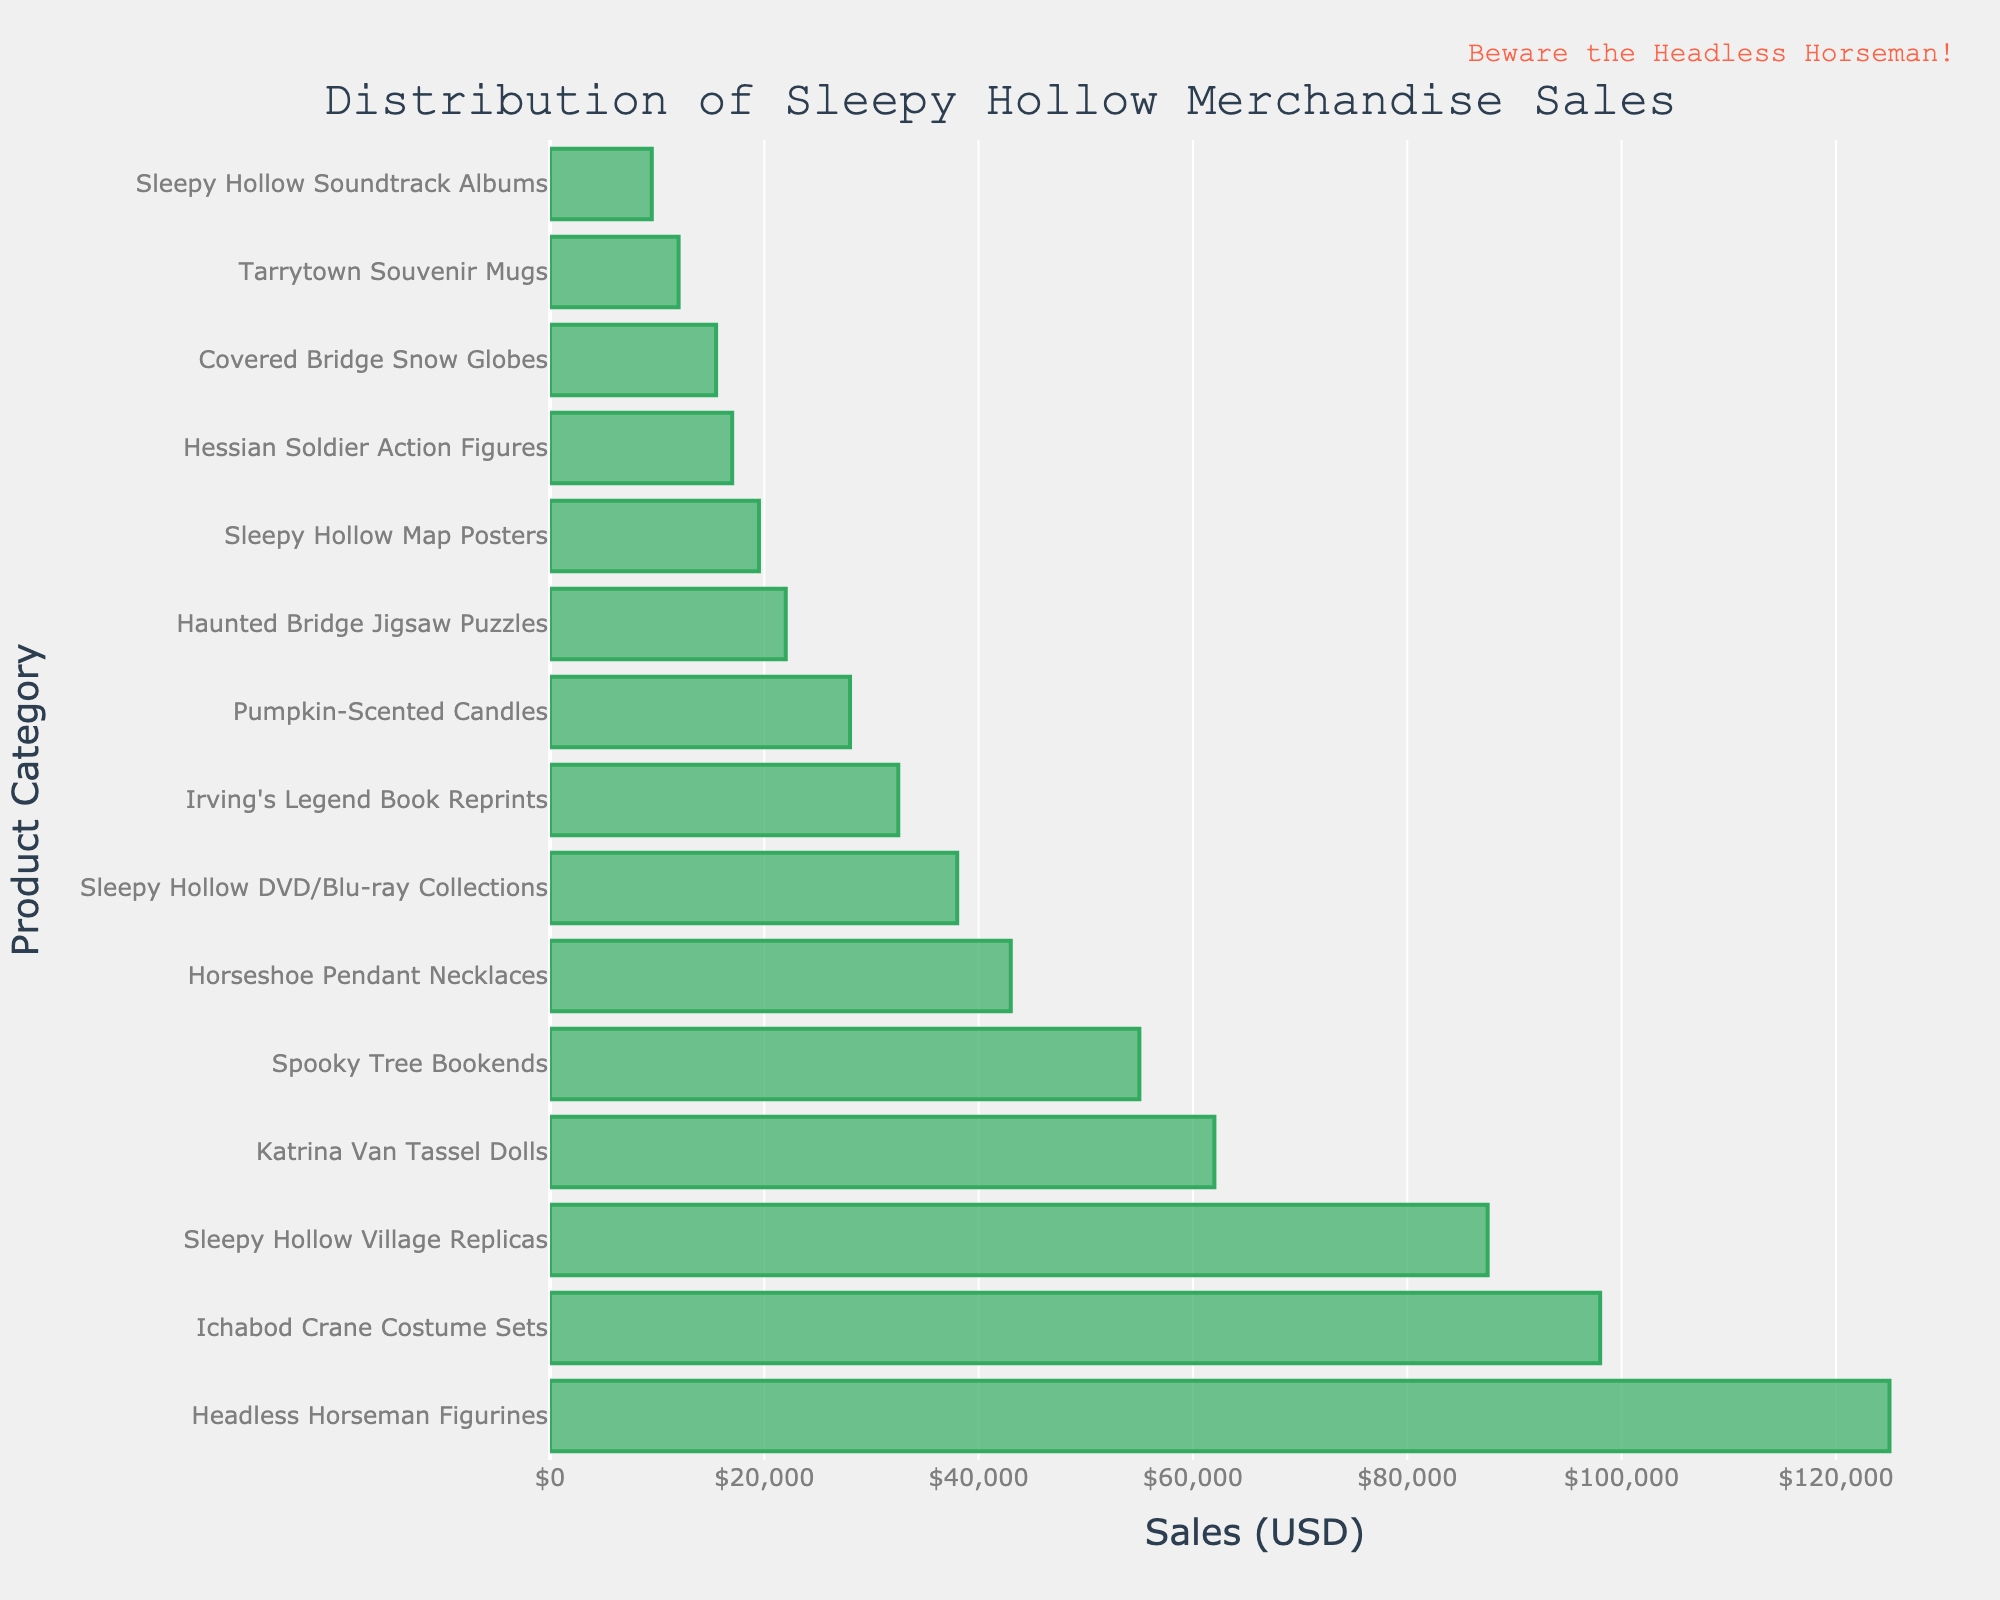Which product category has the highest sales? The product category with the highest sales is represented by the longest bar in the figure. The longest bar corresponds to "Headless Horseman Figurines".
Answer: Headless Horseman Figurines Which product category has the lowest sales? The product category with the lowest sales is represented by the shortest bar in the chart. The shortest bar corresponds to "Sleepy Hollow Soundtrack Albums".
Answer: Sleepy Hollow Soundtrack Albums Are the sales of "Ichabod Crane Costume Sets" higher or lower than "Katrina Van Tassel Dolls"? By comparing the lengths of the bars for "Ichabod Crane Costume Sets" and "Katrina Van Tassel Dolls", it is clear that "Ichabod Crane Costume Sets" has a longer bar, thus higher sales.
Answer: Higher What are the combined sales of "Headless Horseman Figurines" and "Sleepy Hollow Village Replicas"? By summing the sales of "Headless Horseman Figurines" ($125,000) and "Sleepy Hollow Village Replicas" ($87,500), we get $125,000 + $87,500 = $212,500.
Answer: $212,500 How much more did "Katrina Van Tassel Dolls" sell compared to "Horseshoe Pendant Necklaces"? The difference in sales between "Katrina Van Tassel Dolls" ($62,000) and "Horseshoe Pendant Necklaces" ($43,000) is calculated as $62,000 - $43,000 = $19,000.
Answer: $19,000 Which has higher sales: "Spooky Tree Bookends" or "Sleepy Hollow Map Posters"? By comparing the lengths of their bars, "Spooky Tree Bookends" has higher sales than "Sleepy Hollow Map Posters".
Answer: Spooky Tree Bookends What is the total sales of all products related to Sleepy Hollow? To get the total sales, sum all the sales values from each category:
$125,000 + $98,000 + $87,500 + $62,000 + $55,000 + $43,000 + $38,000 + $32,500 + $28,000 + $22,000 + $19,500 + $17,000 + $15,500 + $12,000 + $9,500 = $665,000.
Answer: $665,000 If you ranked the categories by sales, what position does "Irving's Legend Book Reprints" hold? Sorting the sales data in descending order, "Irving's Legend Book Reprints" with $32,500 would be in the 8th position.
Answer: 8th Are the sales of "Haunted Bridge Jigsaw Puzzles" higher than the median sales value of all categories? First, list all sales values in ascending order and find the median. Median is $32,500 since there are 15 values and the 8th value in the list will be median. "Haunted Bridge Jigsaw Puzzles" has sales of $22,000, which is less than $32,500.
Answer: No 